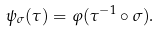<formula> <loc_0><loc_0><loc_500><loc_500>\psi _ { \sigma } ( \tau ) = \varphi ( \tau ^ { - 1 } \circ \sigma ) .</formula> 